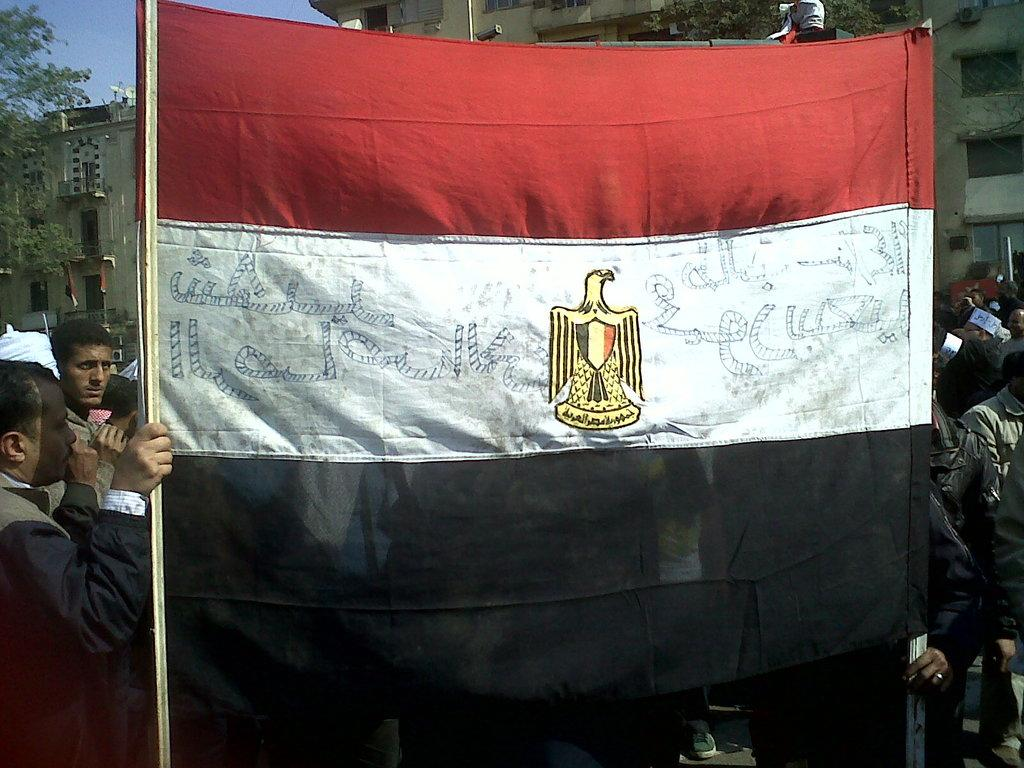What is happening in the image? There are people standing in the image, and two persons are holding a flag in the front. What can be seen in the background of the image? There are buildings, trees, and the sky visible in the background of the image. What type of machine is being used by the friend in the image? There is no friend or machine present in the image. What apparatus is being used by the people in the image? The image does not show any apparatus being used by the people; they are simply holding a flag. 